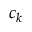<formula> <loc_0><loc_0><loc_500><loc_500>c _ { k }</formula> 